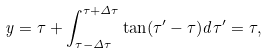<formula> <loc_0><loc_0><loc_500><loc_500>y = \tau + \int _ { \tau - \Delta \tau } ^ { \tau + \Delta \tau } \tan ( \tau ^ { \prime } - \tau ) d \tau ^ { \prime } = \tau ,</formula> 